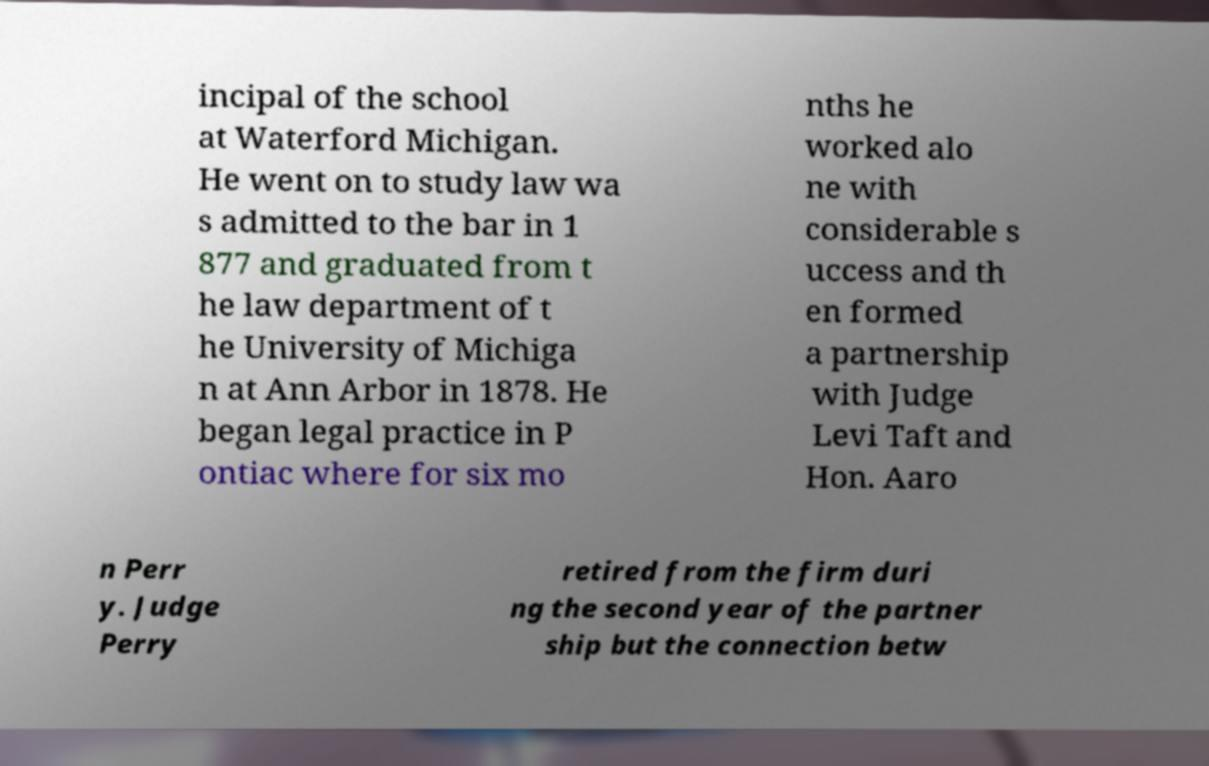For documentation purposes, I need the text within this image transcribed. Could you provide that? incipal of the school at Waterford Michigan. He went on to study law wa s admitted to the bar in 1 877 and graduated from t he law department of t he University of Michiga n at Ann Arbor in 1878. He began legal practice in P ontiac where for six mo nths he worked alo ne with considerable s uccess and th en formed a partnership with Judge Levi Taft and Hon. Aaro n Perr y. Judge Perry retired from the firm duri ng the second year of the partner ship but the connection betw 